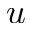Convert formula to latex. <formula><loc_0><loc_0><loc_500><loc_500>u</formula> 